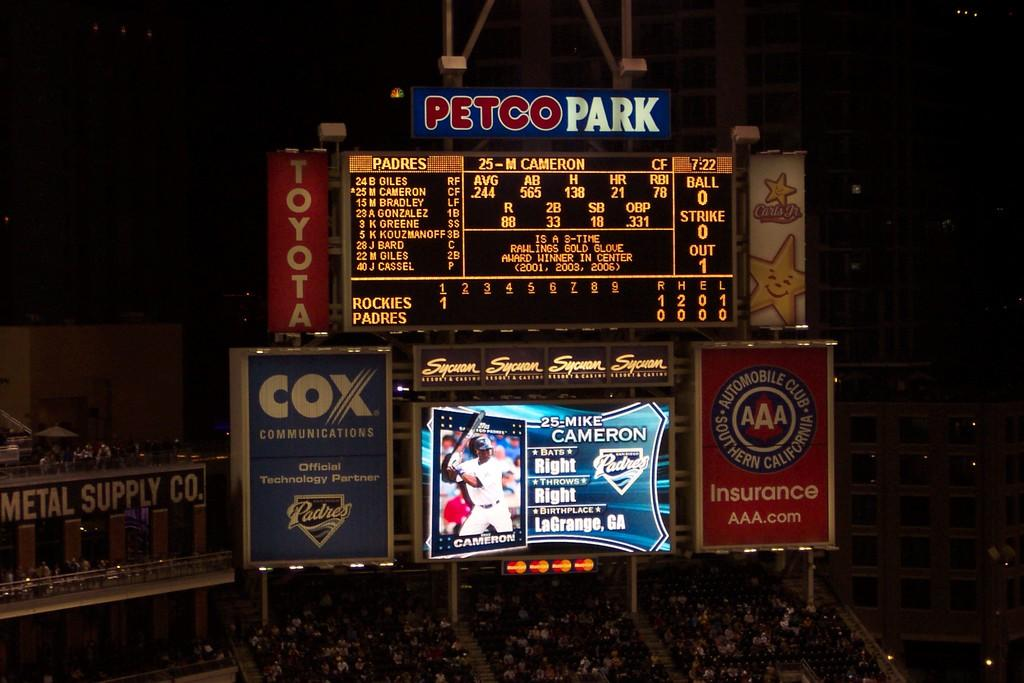<image>
Describe the image concisely. Petco Park Jumbo Screen at night showing Mike Cameron for the San Diego Padres, who is up to bat. 